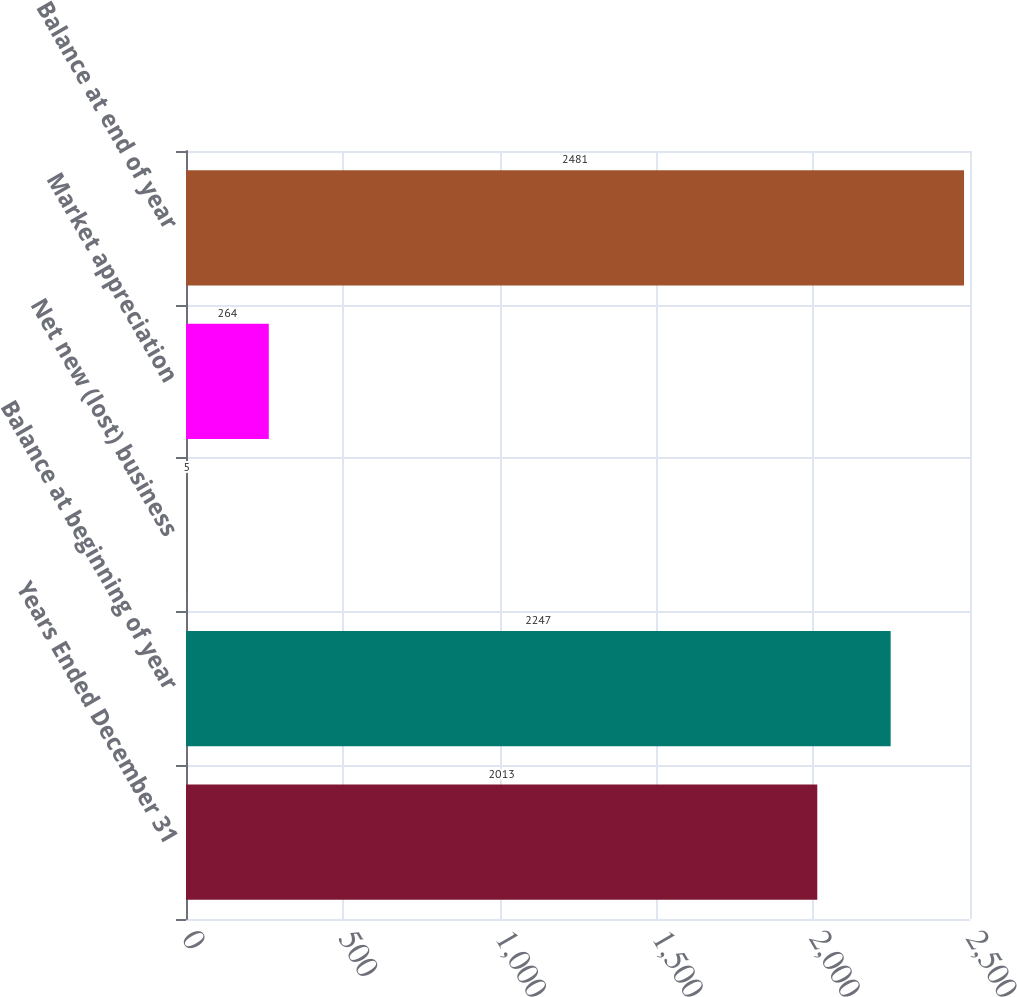Convert chart to OTSL. <chart><loc_0><loc_0><loc_500><loc_500><bar_chart><fcel>Years Ended December 31<fcel>Balance at beginning of year<fcel>Net new (lost) business<fcel>Market appreciation<fcel>Balance at end of year<nl><fcel>2013<fcel>2247<fcel>5<fcel>264<fcel>2481<nl></chart> 